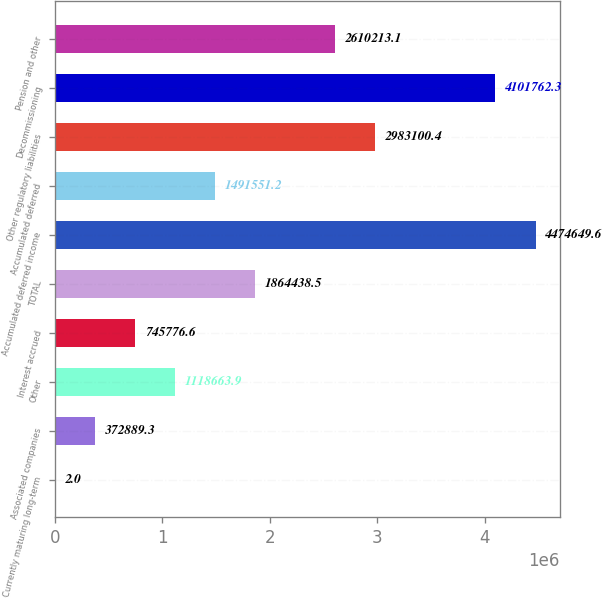Convert chart to OTSL. <chart><loc_0><loc_0><loc_500><loc_500><bar_chart><fcel>Currently maturing long-term<fcel>Associated companies<fcel>Other<fcel>Interest accrued<fcel>TOTAL<fcel>Accumulated deferred income<fcel>Accumulated deferred<fcel>Other regulatory liabilities<fcel>Decommissioning<fcel>Pension and other<nl><fcel>2<fcel>372889<fcel>1.11866e+06<fcel>745777<fcel>1.86444e+06<fcel>4.47465e+06<fcel>1.49155e+06<fcel>2.9831e+06<fcel>4.10176e+06<fcel>2.61021e+06<nl></chart> 